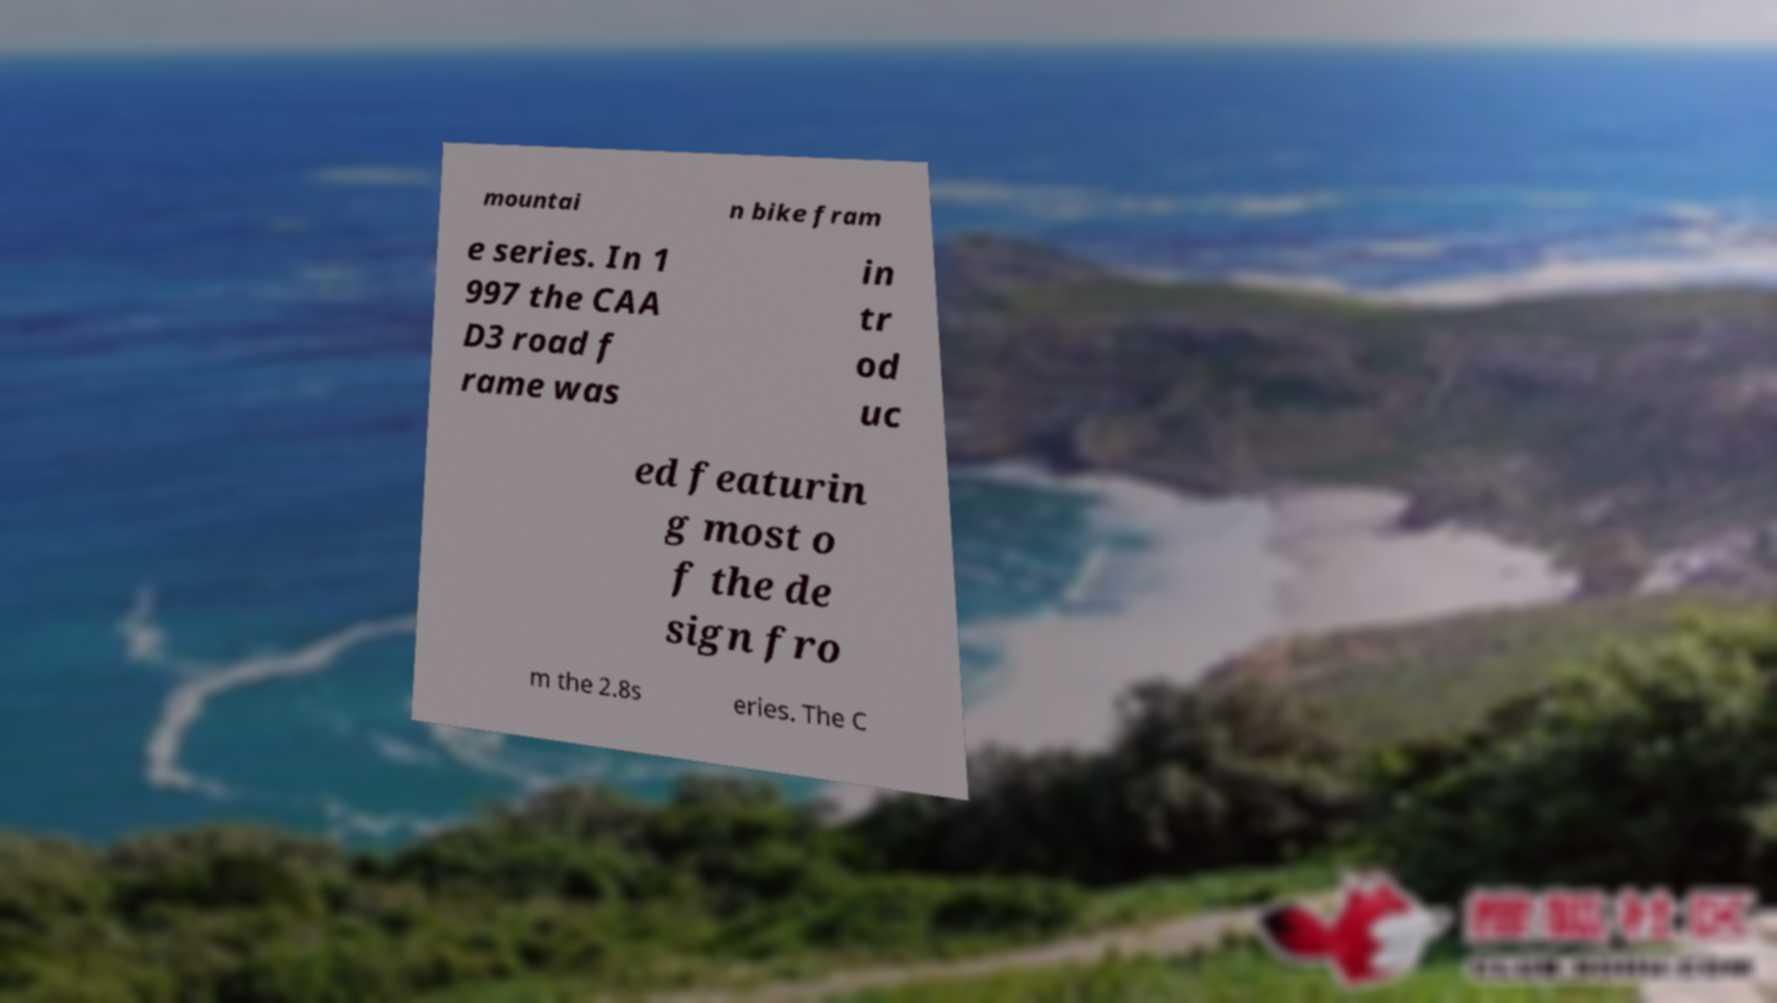Could you extract and type out the text from this image? mountai n bike fram e series. In 1 997 the CAA D3 road f rame was in tr od uc ed featurin g most o f the de sign fro m the 2.8s eries. The C 